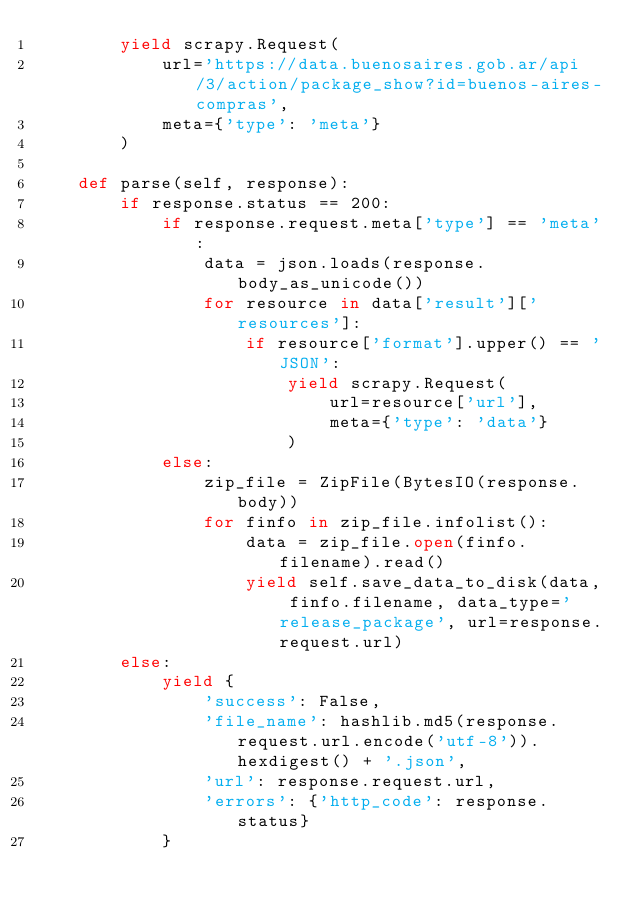Convert code to text. <code><loc_0><loc_0><loc_500><loc_500><_Python_>        yield scrapy.Request(
            url='https://data.buenosaires.gob.ar/api/3/action/package_show?id=buenos-aires-compras',
            meta={'type': 'meta'}
        )

    def parse(self, response):
        if response.status == 200:
            if response.request.meta['type'] == 'meta':
                data = json.loads(response.body_as_unicode())
                for resource in data['result']['resources']:
                    if resource['format'].upper() == 'JSON':
                        yield scrapy.Request(
                            url=resource['url'],
                            meta={'type': 'data'}
                        )
            else:
                zip_file = ZipFile(BytesIO(response.body))
                for finfo in zip_file.infolist():
                    data = zip_file.open(finfo.filename).read()
                    yield self.save_data_to_disk(data, finfo.filename, data_type='release_package', url=response.request.url)
        else:
            yield {
                'success': False,
                'file_name': hashlib.md5(response.request.url.encode('utf-8')).hexdigest() + '.json',
                'url': response.request.url,
                'errors': {'http_code': response.status}
            }
</code> 